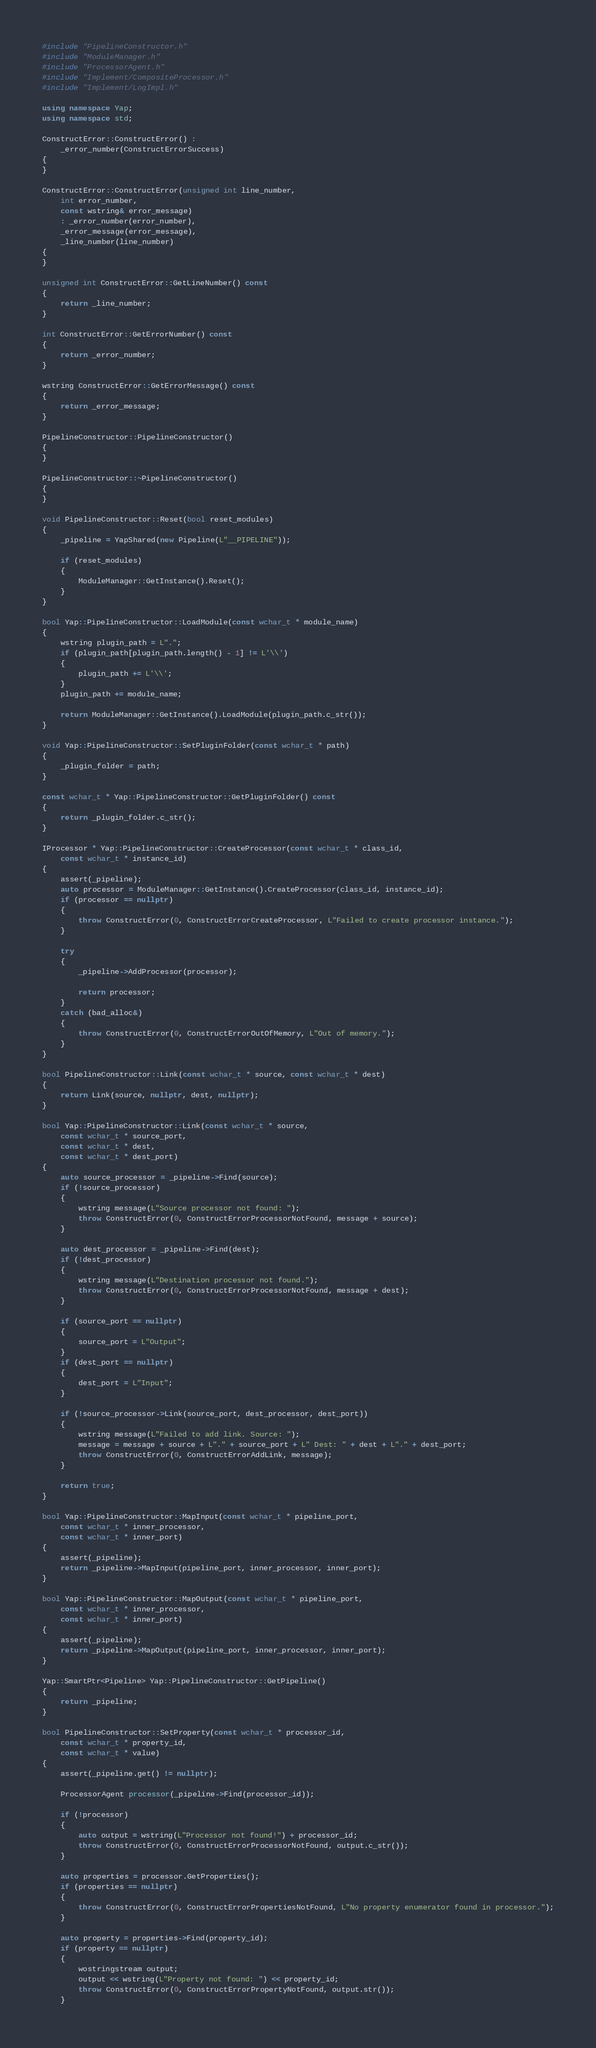<code> <loc_0><loc_0><loc_500><loc_500><_C++_>#include "PipelineConstructor.h"
#include "ModuleManager.h"
#include "ProcessorAgent.h"
#include "Implement/CompositeProcessor.h"
#include "Implement/LogImpl.h"

using namespace Yap;
using namespace std;

ConstructError::ConstructError() :
	_error_number(ConstructErrorSuccess)
{
}

ConstructError::ConstructError(unsigned int line_number,
	int error_number,
	const wstring& error_message)
	: _error_number(error_number),
	_error_message(error_message),
	_line_number(line_number)
{
}

unsigned int ConstructError::GetLineNumber() const
{
	return _line_number;
}

int ConstructError::GetErrorNumber() const
{
	return _error_number;
}

wstring ConstructError::GetErrorMessage() const
{
	return _error_message;
}

PipelineConstructor::PipelineConstructor()
{
}

PipelineConstructor::~PipelineConstructor()
{
}

void PipelineConstructor::Reset(bool reset_modules)
{
    _pipeline = YapShared(new Pipeline(L"__PIPELINE"));

	if (reset_modules)
    {
		ModuleManager::GetInstance().Reset();
    }
}

bool Yap::PipelineConstructor::LoadModule(const wchar_t * module_name)
{
	wstring plugin_path = L".";
	if (plugin_path[plugin_path.length() - 1] != L'\\')
	{
		plugin_path += L'\\';
	}
	plugin_path += module_name;

	return ModuleManager::GetInstance().LoadModule(plugin_path.c_str());
}

void Yap::PipelineConstructor::SetPluginFolder(const wchar_t * path)
{
	_plugin_folder = path;
}

const wchar_t * Yap::PipelineConstructor::GetPluginFolder() const
{
	return _plugin_folder.c_str();
}

IProcessor * Yap::PipelineConstructor::CreateProcessor(const wchar_t * class_id,
	const wchar_t * instance_id)
{
	assert(_pipeline);
	auto processor = ModuleManager::GetInstance().CreateProcessor(class_id, instance_id);
	if (processor == nullptr)
	{
		throw ConstructError(0, ConstructErrorCreateProcessor, L"Failed to create processor instance.");
	}

	try
	{
		_pipeline->AddProcessor(processor);

		return processor;
	}
	catch (bad_alloc&)
	{
		throw ConstructError(0, ConstructErrorOutOfMemory, L"Out of memory.");
	}
}

bool PipelineConstructor::Link(const wchar_t * source, const wchar_t * dest)
{
	return Link(source, nullptr, dest, nullptr);
}

bool Yap::PipelineConstructor::Link(const wchar_t * source, 
	const wchar_t * source_port, 
	const wchar_t * dest, 
	const wchar_t * dest_port)
{
	auto source_processor = _pipeline->Find(source);
	if (!source_processor)
	{
		wstring message(L"Source processor not found: ");
		throw ConstructError(0, ConstructErrorProcessorNotFound, message + source);
	}

	auto dest_processor = _pipeline->Find(dest);
	if (!dest_processor)
	{
		wstring message(L"Destination processor not found.");
		throw ConstructError(0, ConstructErrorProcessorNotFound, message + dest);
	}

	if (source_port == nullptr)
	{
		source_port = L"Output";
	}
	if (dest_port == nullptr)
	{
		dest_port = L"Input";
	}

	if (!source_processor->Link(source_port, dest_processor, dest_port))
	{
		wstring message(L"Failed to add link. Source: ");
		message = message + source + L"." + source_port + L" Dest: " + dest + L"." + dest_port;
		throw ConstructError(0, ConstructErrorAddLink, message);
	}

	return true;
}

bool Yap::PipelineConstructor::MapInput(const wchar_t * pipeline_port, 
	const wchar_t * inner_processor, 
	const wchar_t * inner_port)
{
	assert(_pipeline);
	return _pipeline->MapInput(pipeline_port, inner_processor, inner_port);
}

bool Yap::PipelineConstructor::MapOutput(const wchar_t * pipeline_port, 
	const wchar_t * inner_processor, 
	const wchar_t * inner_port)
{
	assert(_pipeline);
	return _pipeline->MapOutput(pipeline_port, inner_processor, inner_port);
}

Yap::SmartPtr<Pipeline> Yap::PipelineConstructor::GetPipeline()
{
	return _pipeline;
}

bool PipelineConstructor::SetProperty(const wchar_t * processor_id,
	const wchar_t * property_id,
	const wchar_t * value)
{
    assert(_pipeline.get() != nullptr);

	ProcessorAgent processor(_pipeline->Find(processor_id));

	if (!processor)
	{
        auto output = wstring(L"Processor not found!") + processor_id;
		throw ConstructError(0, ConstructErrorProcessorNotFound, output.c_str());
	}

	auto properties = processor.GetProperties();
	if (properties == nullptr)
	{
		throw ConstructError(0, ConstructErrorPropertiesNotFound, L"No property enumerator found in processor.");
	}

	auto property = properties->Find(property_id);
	if (property == nullptr)
	{
		wostringstream output;
		output << wstring(L"Property not found: ") << property_id;
		throw ConstructError(0, ConstructErrorPropertyNotFound, output.str());
	}
</code> 